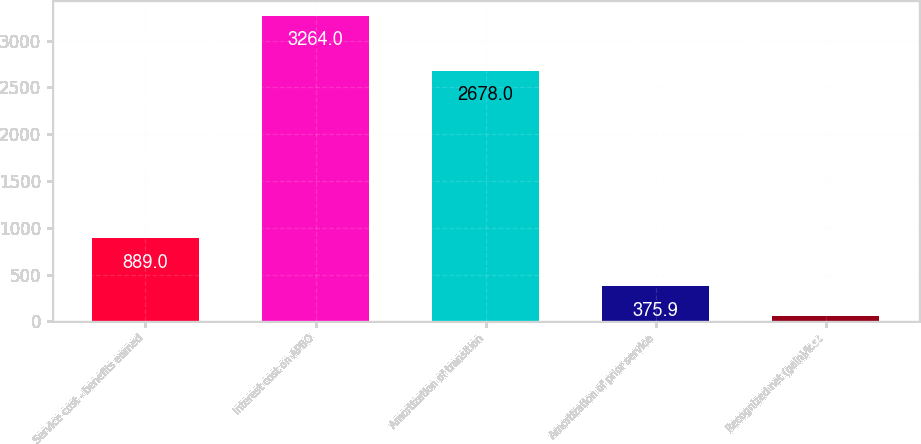Convert chart to OTSL. <chart><loc_0><loc_0><loc_500><loc_500><bar_chart><fcel>Service cost - benefits earned<fcel>Interest cost on APBO<fcel>Amortization of transition<fcel>Amortization of prior service<fcel>Recognized net (gain)/loss<nl><fcel>889<fcel>3264<fcel>2678<fcel>375.9<fcel>55<nl></chart> 